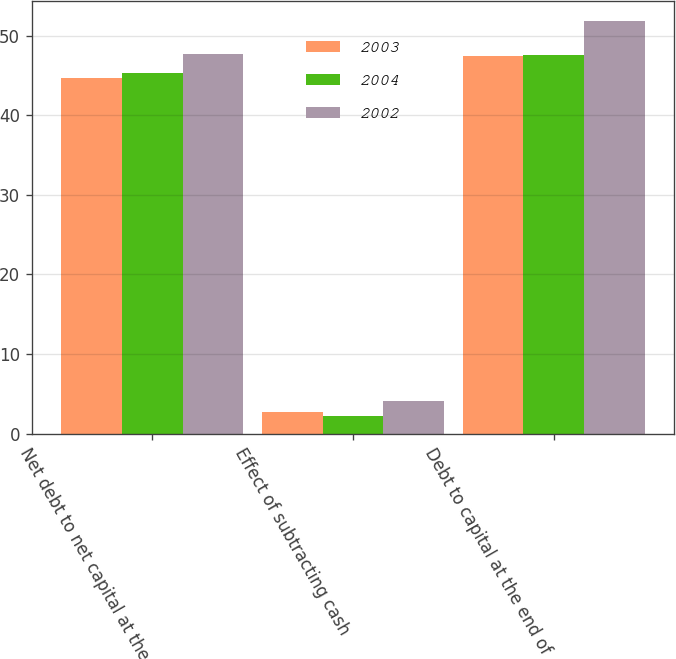<chart> <loc_0><loc_0><loc_500><loc_500><stacked_bar_chart><ecel><fcel>Net debt to net capital at the<fcel>Effect of subtracting cash<fcel>Debt to capital at the end of<nl><fcel>2003<fcel>44.7<fcel>2.7<fcel>47.4<nl><fcel>2004<fcel>45.3<fcel>2.2<fcel>47.5<nl><fcel>2002<fcel>47.7<fcel>4.1<fcel>51.8<nl></chart> 